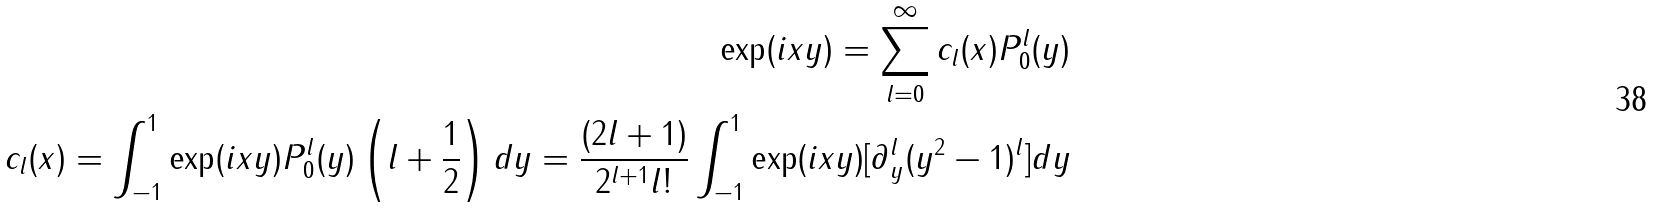Convert formula to latex. <formula><loc_0><loc_0><loc_500><loc_500>\exp ( i x y ) = \sum _ { l = 0 } ^ { \infty } c _ { l } ( x ) P _ { 0 } ^ { l } ( y ) \\ c _ { l } ( x ) = \int _ { - 1 } ^ { 1 } \exp ( i x y ) P _ { 0 } ^ { l } ( y ) \left ( l + \frac { 1 } { 2 } \right ) d y = \frac { ( 2 l + 1 ) } { 2 ^ { l + 1 } l ! } \int _ { - 1 } ^ { 1 } \exp ( i x y ) [ \partial _ { y } ^ { l } ( y ^ { 2 } - 1 ) ^ { l } ] d y</formula> 